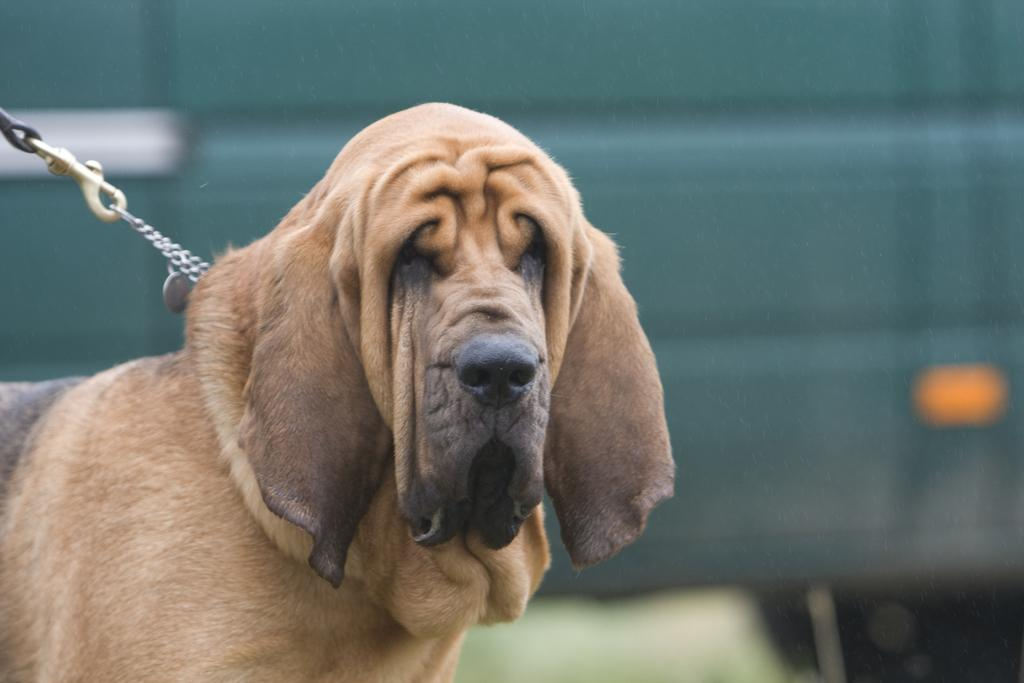What animal can be seen in the picture? There is a dog in the picture. How is the dog restrained in the image? The dog is attached to a chain. Can you describe the background of the image? The background of the image is blurred. What type of sock is the dog wearing in the image? There is no sock present in the image, as the dog is not wearing any clothing. 